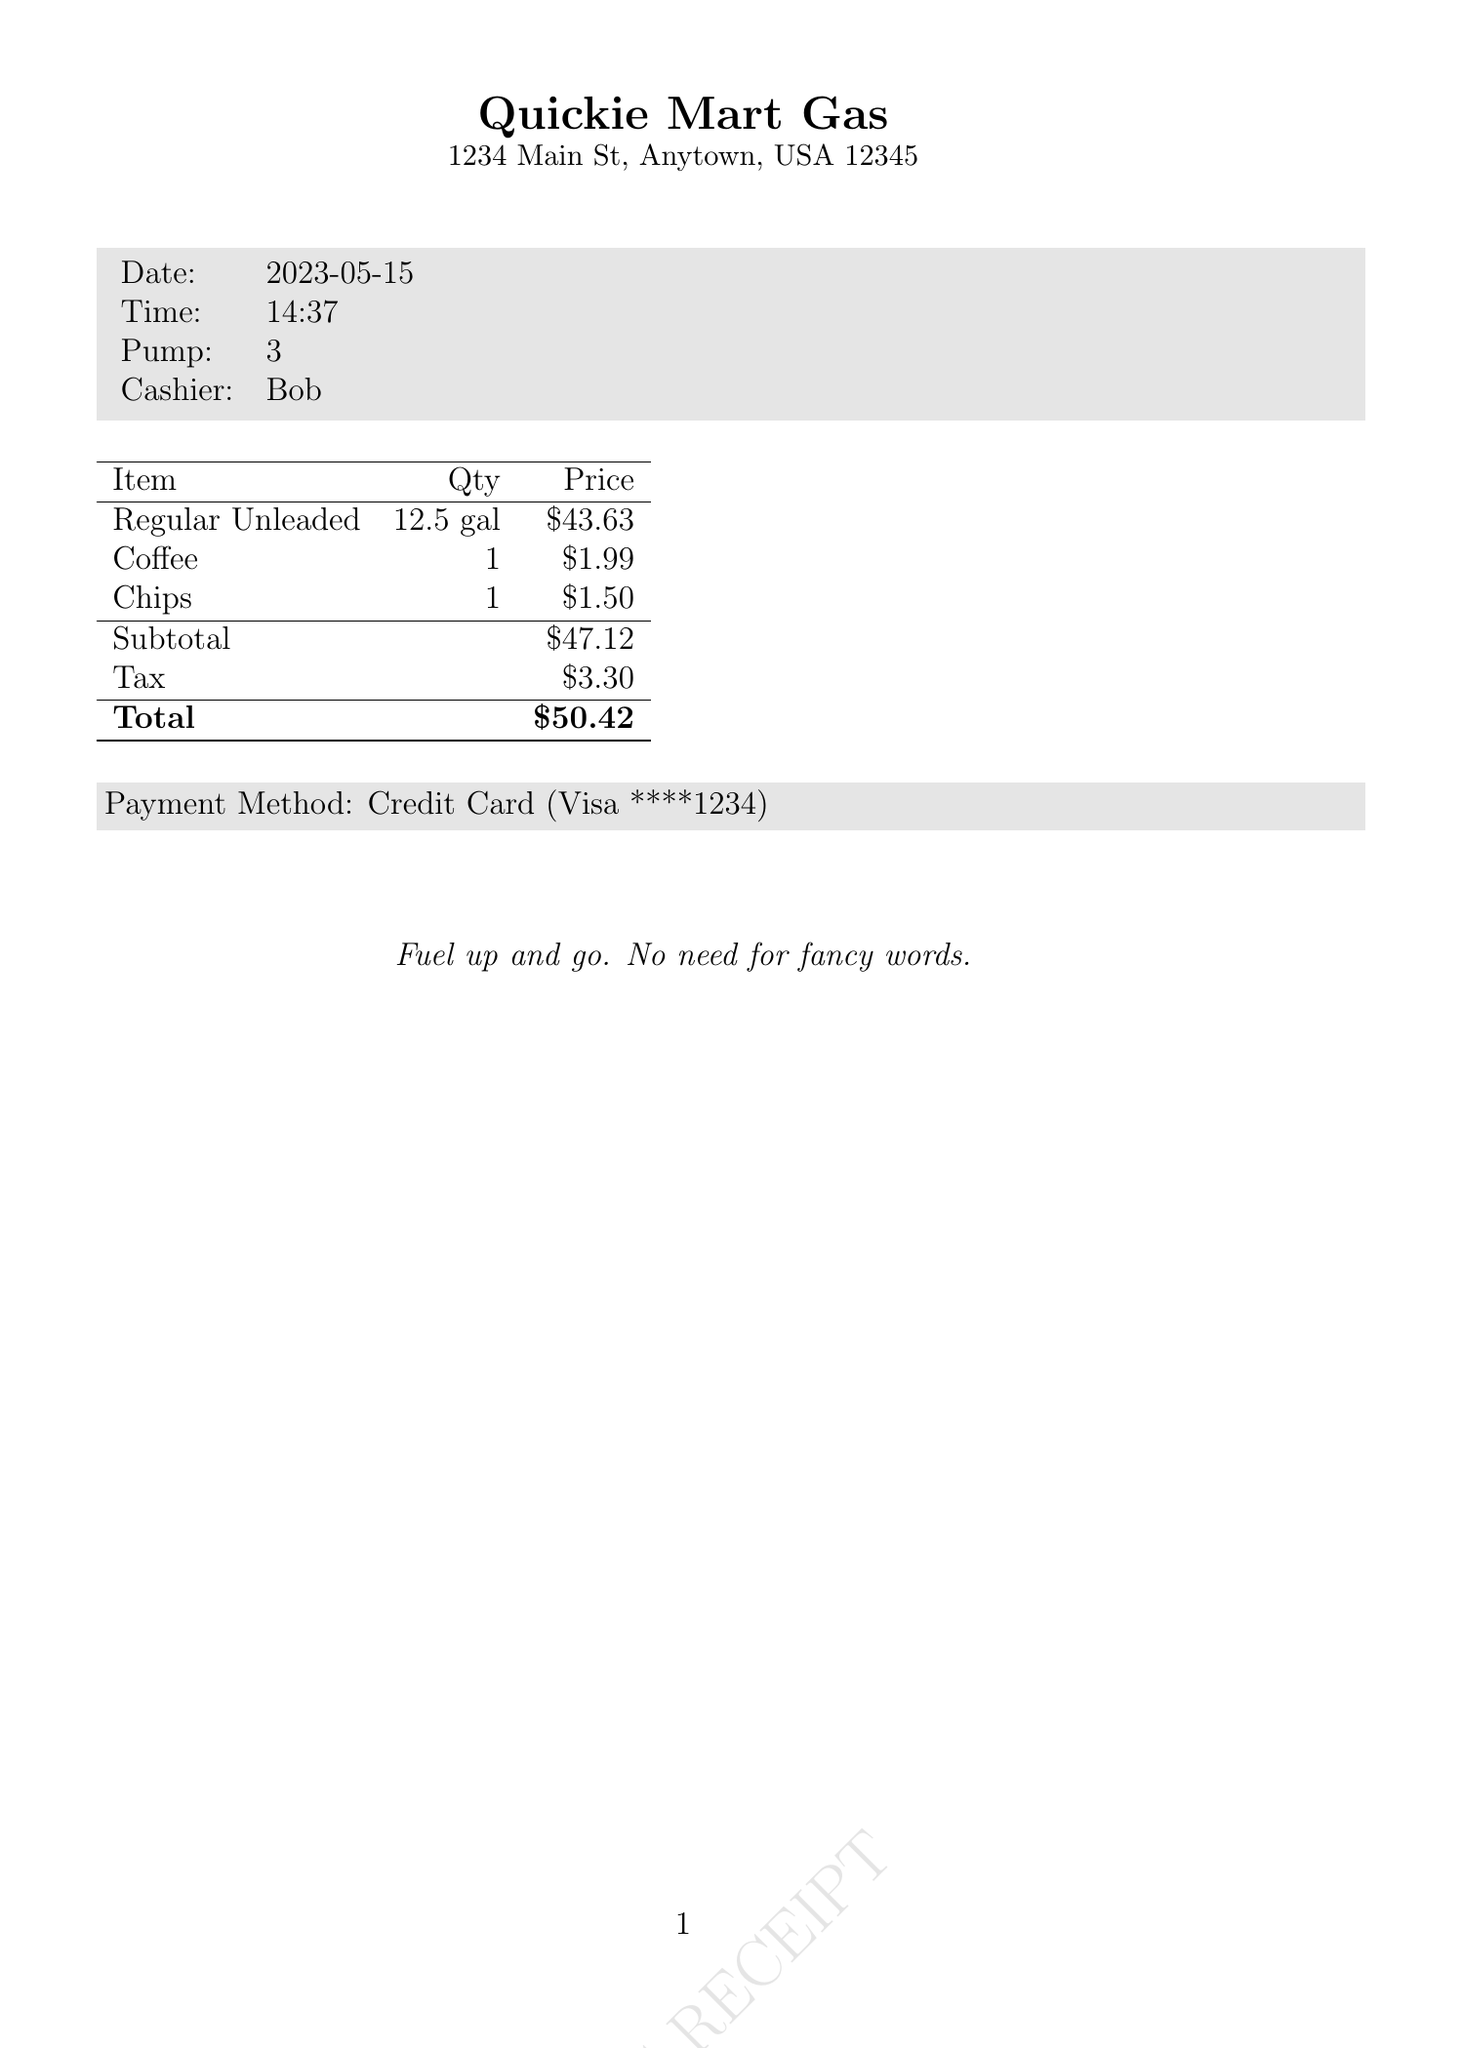What is the name of the gas station? The document clearly states the name of the gas station at the top.
Answer: Quickie Mart Gas What type of fuel was purchased? The selected fuel type is mentioned in the tabulated section of the document.
Answer: Regular Unleaded How many gallons were pumped? The number of gallons pumped is indicated next to the fuel type.
Answer: 12.5 What is the total amount paid? The total amount paid is highlighted at the end of the tabulated section in the document.
Answer: $50.42 What was the price per gallon of diesel? The price per gallon for diesel is provided in the fuel types section.
Answer: $3.99 What was the subtotal before tax? The subtotal is listed before the tax amount in the tabulated section.
Answer: $47.12 Who was the cashier? The name of the cashier is mentioned in the introductory data section.
Answer: Bob What payment method was used? The payment method is specifically outlined near the end of the receipt.
Answer: Credit Card How much tax was charged? The amount of tax is specified in the tabulated section of the document.
Answer: $3.30 